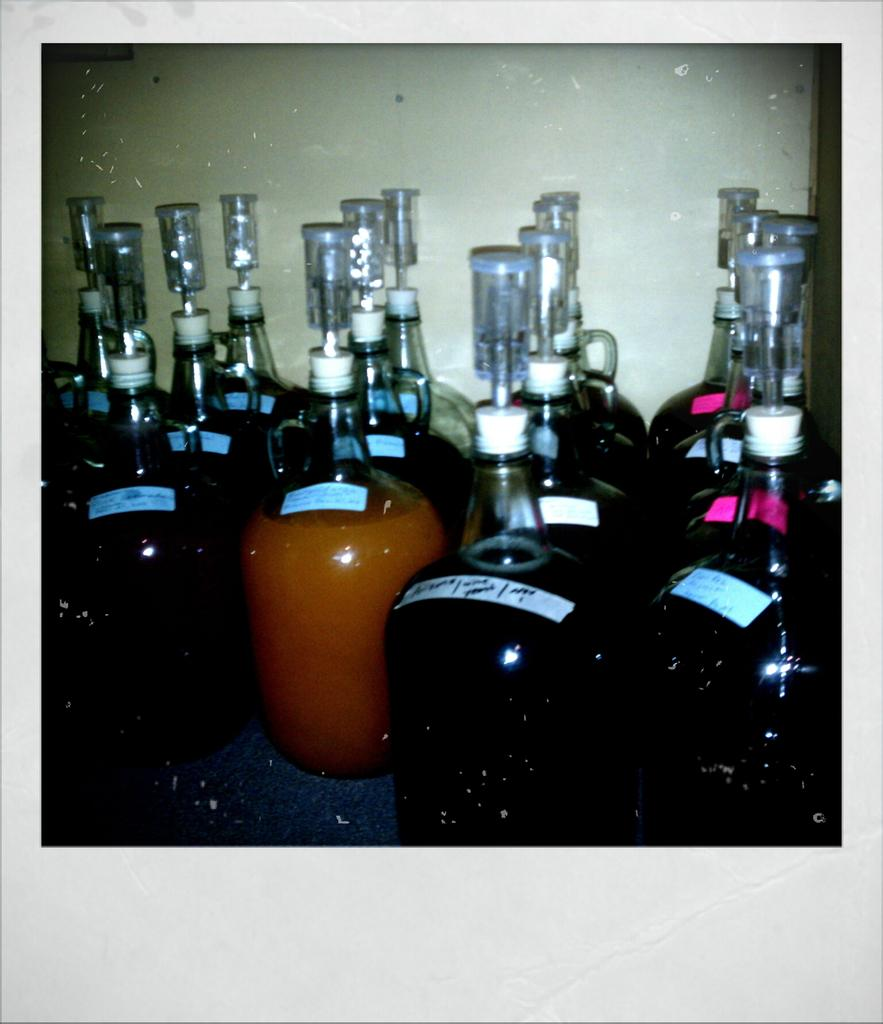What color are the bottles in the image? The bottles in the image are black and orange. Can you describe the orange bottle in the image? The orange bottle has a label on it. What else can be seen in the image related to the bottles? There are different kinds of kids (possibly referring to caps or lids) in the image. What type of bait is being used to catch fish in the image? There is no bait or fishing activity present in the image; it features bottles and different kinds of kids (possibly referring to caps or lids). 